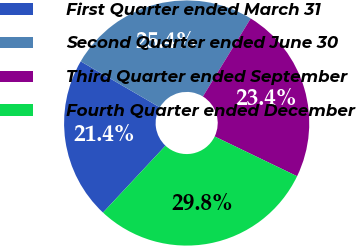Convert chart. <chart><loc_0><loc_0><loc_500><loc_500><pie_chart><fcel>First Quarter ended March 31<fcel>Second Quarter ended June 30<fcel>Third Quarter ended September<fcel>Fourth Quarter ended December<nl><fcel>21.43%<fcel>25.36%<fcel>23.4%<fcel>29.8%<nl></chart> 